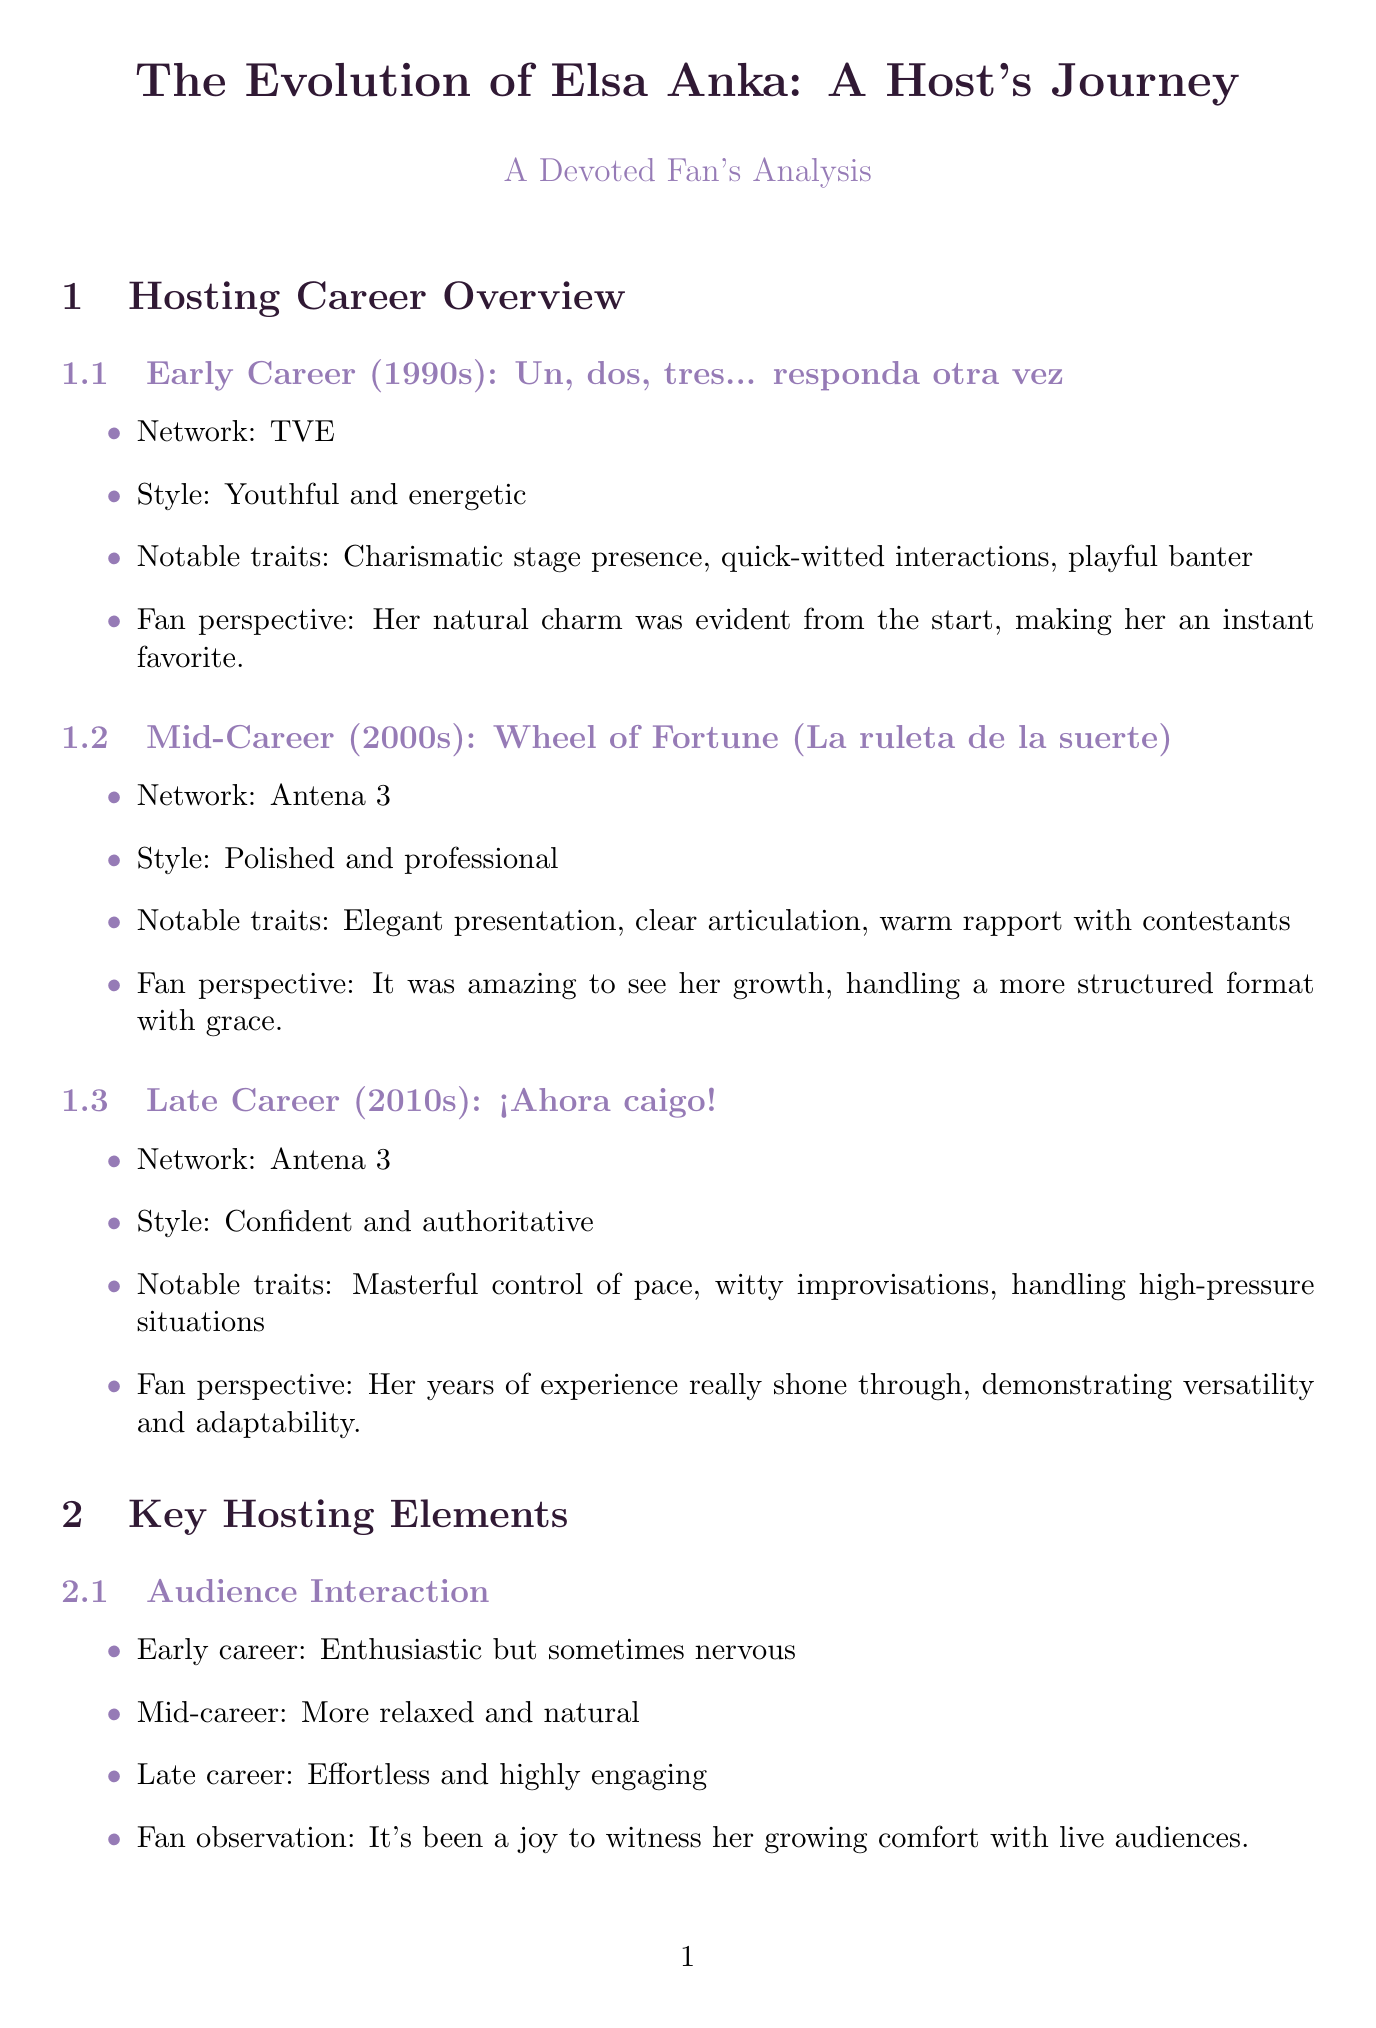What show marked Elsa Anka's early career? The document states that her early career show was "Un, dos, tres... responda otra vez."
Answer: Un, dos, tres... responda otra vez What was Elsa's hosting style in the 2000s? According to the document, her style in the mid-career was "Polished and professional."
Answer: Polished and professional In what year did Elsa have an impromptu dance number? The document mentions that this moment occurred in 1993.
Answer: 1993 How did Elsa's audience interaction style evolve by the late career? The document states that her late-career audience interaction style was "Effortless and highly engaging."
Answer: Effortless and highly engaging What improvement was noted in Elsa's vocal delivery by the late career? The document highlights that her late-career vocal delivery was characterized by a "Confident and authoritative tone."
Answer: Confident and authoritative tone Which show featured Elsa comforting a contestant after a loss? The document specifies that this happened on "Wheel of Fortune."
Answer: Wheel of Fortune What significant aspect of Elsa's on-screen persona changed by the late career? According to the document, she became "Warm, witty, and self-assured" in her late career.
Answer: Warm, witty, and self-assured What is a key trait of Elsa's mid-career hosting style? The document notes "Elegant presentation" as a key trait of her mid-career style.
Answer: Elegant presentation In which decade did Elsa display a youthful and energetic hosting style? The document indicates she displayed this style in the 1990s.
Answer: 1990s 